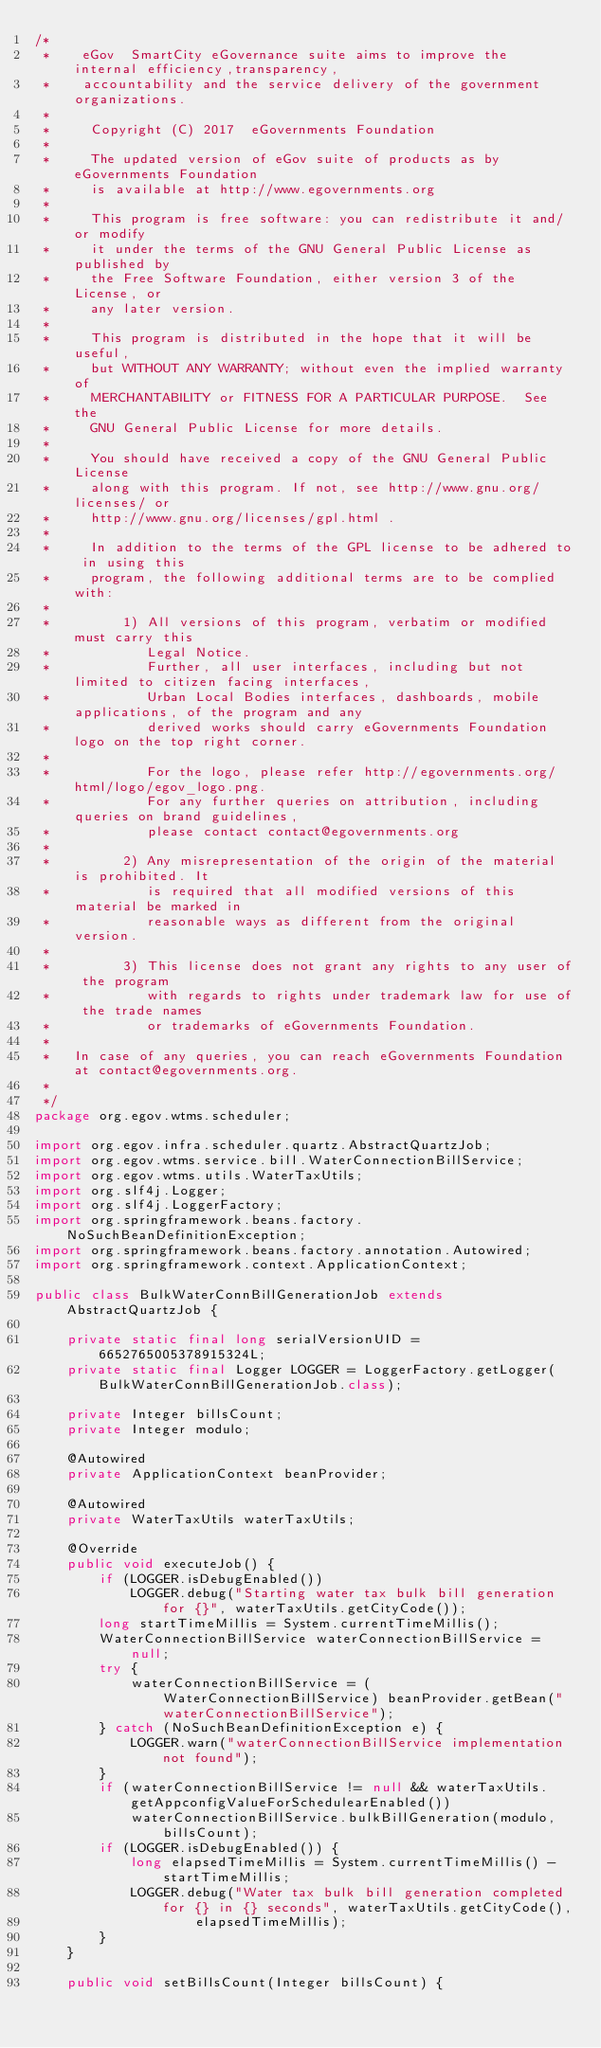Convert code to text. <code><loc_0><loc_0><loc_500><loc_500><_Java_>/*
 *    eGov  SmartCity eGovernance suite aims to improve the internal efficiency,transparency,
 *    accountability and the service delivery of the government  organizations.
 *
 *     Copyright (C) 2017  eGovernments Foundation
 *
 *     The updated version of eGov suite of products as by eGovernments Foundation
 *     is available at http://www.egovernments.org
 *
 *     This program is free software: you can redistribute it and/or modify
 *     it under the terms of the GNU General Public License as published by
 *     the Free Software Foundation, either version 3 of the License, or
 *     any later version.
 *
 *     This program is distributed in the hope that it will be useful,
 *     but WITHOUT ANY WARRANTY; without even the implied warranty of
 *     MERCHANTABILITY or FITNESS FOR A PARTICULAR PURPOSE.  See the
 *     GNU General Public License for more details.
 *
 *     You should have received a copy of the GNU General Public License
 *     along with this program. If not, see http://www.gnu.org/licenses/ or
 *     http://www.gnu.org/licenses/gpl.html .
 *
 *     In addition to the terms of the GPL license to be adhered to in using this
 *     program, the following additional terms are to be complied with:
 *
 *         1) All versions of this program, verbatim or modified must carry this
 *            Legal Notice.
 *            Further, all user interfaces, including but not limited to citizen facing interfaces,
 *            Urban Local Bodies interfaces, dashboards, mobile applications, of the program and any
 *            derived works should carry eGovernments Foundation logo on the top right corner.
 *
 *            For the logo, please refer http://egovernments.org/html/logo/egov_logo.png.
 *            For any further queries on attribution, including queries on brand guidelines,
 *            please contact contact@egovernments.org
 *
 *         2) Any misrepresentation of the origin of the material is prohibited. It
 *            is required that all modified versions of this material be marked in
 *            reasonable ways as different from the original version.
 *
 *         3) This license does not grant any rights to any user of the program
 *            with regards to rights under trademark law for use of the trade names
 *            or trademarks of eGovernments Foundation.
 *
 *   In case of any queries, you can reach eGovernments Foundation at contact@egovernments.org.
 *
 */
package org.egov.wtms.scheduler;

import org.egov.infra.scheduler.quartz.AbstractQuartzJob;
import org.egov.wtms.service.bill.WaterConnectionBillService;
import org.egov.wtms.utils.WaterTaxUtils;
import org.slf4j.Logger;
import org.slf4j.LoggerFactory;
import org.springframework.beans.factory.NoSuchBeanDefinitionException;
import org.springframework.beans.factory.annotation.Autowired;
import org.springframework.context.ApplicationContext;

public class BulkWaterConnBillGenerationJob extends AbstractQuartzJob {

    private static final long serialVersionUID = 6652765005378915324L;
    private static final Logger LOGGER = LoggerFactory.getLogger(BulkWaterConnBillGenerationJob.class);

    private Integer billsCount;
    private Integer modulo;

    @Autowired
    private ApplicationContext beanProvider;

    @Autowired
    private WaterTaxUtils waterTaxUtils;

    @Override
    public void executeJob() {
        if (LOGGER.isDebugEnabled())
            LOGGER.debug("Starting water tax bulk bill generation for {}", waterTaxUtils.getCityCode());
        long startTimeMillis = System.currentTimeMillis();
        WaterConnectionBillService waterConnectionBillService = null;
        try {
            waterConnectionBillService = (WaterConnectionBillService) beanProvider.getBean("waterConnectionBillService");
        } catch (NoSuchBeanDefinitionException e) {
            LOGGER.warn("waterConnectionBillService implementation not found");
        }
        if (waterConnectionBillService != null && waterTaxUtils.getAppconfigValueForSchedulearEnabled())
            waterConnectionBillService.bulkBillGeneration(modulo, billsCount);
        if (LOGGER.isDebugEnabled()) {
            long elapsedTimeMillis = System.currentTimeMillis() - startTimeMillis;
            LOGGER.debug("Water tax bulk bill generation completed for {} in {} seconds", waterTaxUtils.getCityCode(),
                    elapsedTimeMillis);
        }
    }

    public void setBillsCount(Integer billsCount) {</code> 